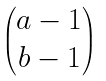Convert formula to latex. <formula><loc_0><loc_0><loc_500><loc_500>\begin{pmatrix} a - 1 \\ b - 1 \end{pmatrix}</formula> 